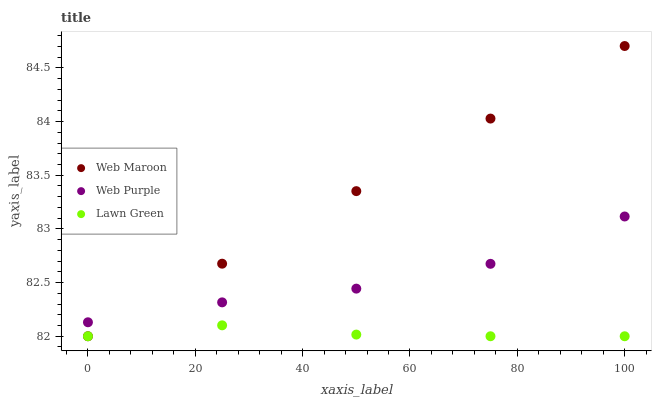Does Lawn Green have the minimum area under the curve?
Answer yes or no. Yes. Does Web Maroon have the maximum area under the curve?
Answer yes or no. Yes. Does Web Purple have the minimum area under the curve?
Answer yes or no. No. Does Web Purple have the maximum area under the curve?
Answer yes or no. No. Is Web Maroon the smoothest?
Answer yes or no. Yes. Is Web Purple the roughest?
Answer yes or no. Yes. Is Web Purple the smoothest?
Answer yes or no. No. Is Web Maroon the roughest?
Answer yes or no. No. Does Lawn Green have the lowest value?
Answer yes or no. Yes. Does Web Purple have the lowest value?
Answer yes or no. No. Does Web Maroon have the highest value?
Answer yes or no. Yes. Does Web Purple have the highest value?
Answer yes or no. No. Is Lawn Green less than Web Purple?
Answer yes or no. Yes. Is Web Purple greater than Lawn Green?
Answer yes or no. Yes. Does Web Maroon intersect Web Purple?
Answer yes or no. Yes. Is Web Maroon less than Web Purple?
Answer yes or no. No. Is Web Maroon greater than Web Purple?
Answer yes or no. No. Does Lawn Green intersect Web Purple?
Answer yes or no. No. 